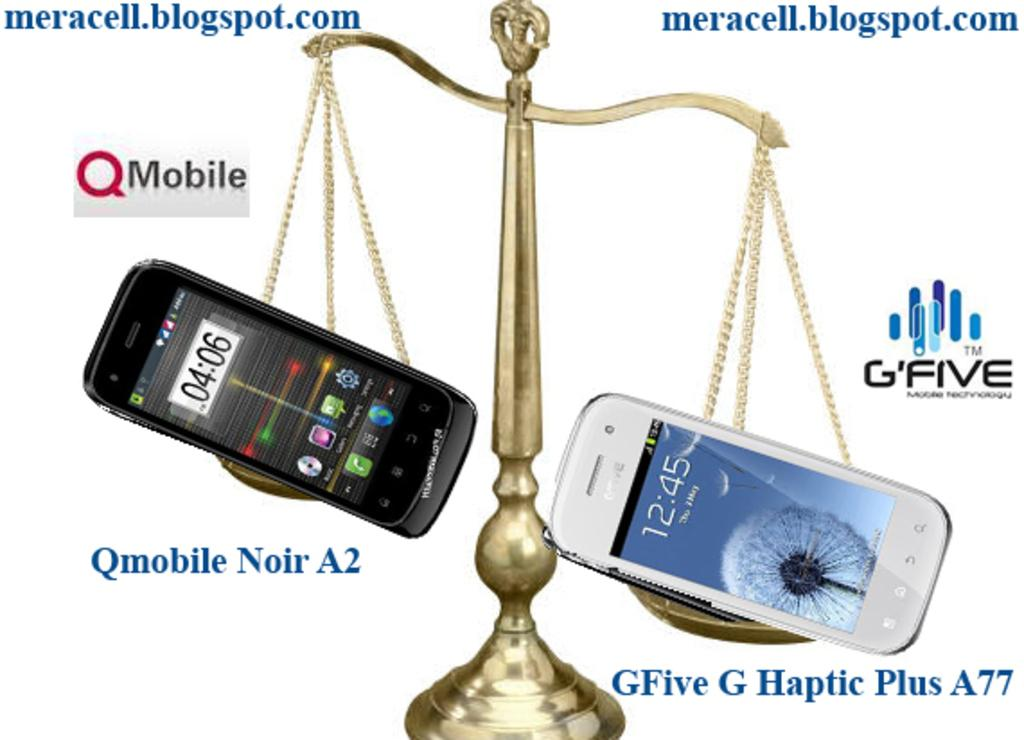<image>
Describe the image concisely. The GFive G Haptic Plus A77 appears to weight a little more than the Qmobile Noir A2. 